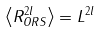Convert formula to latex. <formula><loc_0><loc_0><loc_500><loc_500>\left < R ^ { 2 l } _ { O R S } \right > = L ^ { 2 l }</formula> 